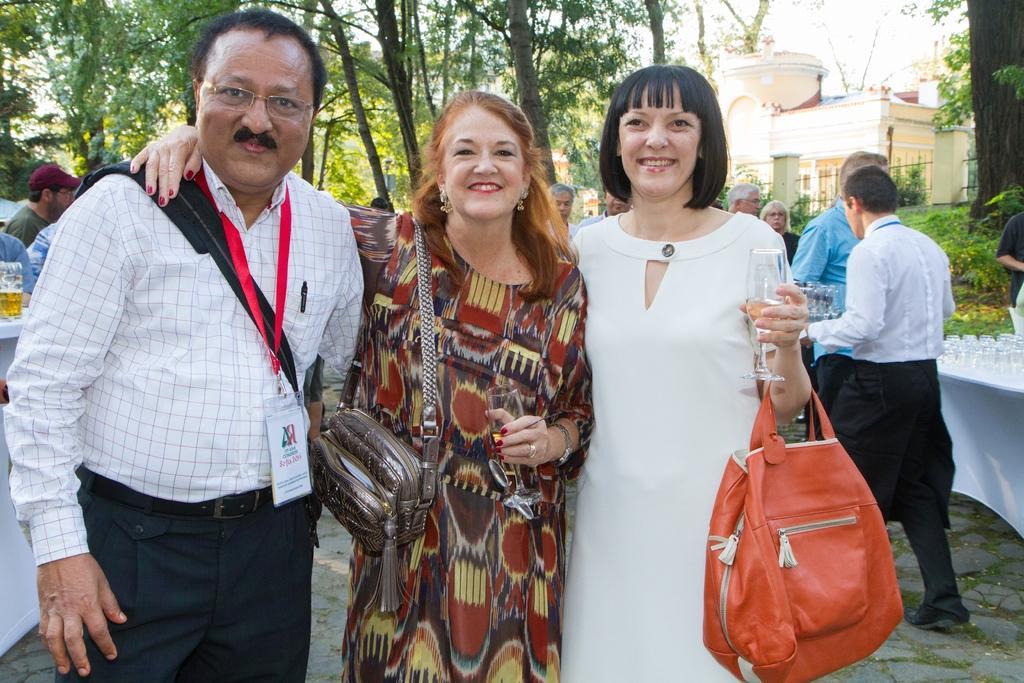Describe this image in one or two sentences. On the background we can see trees, buildings. Here we can see few persons standing. We can see water glasses on the table. Here we can see three persons standing in front of a picture and smiling. 